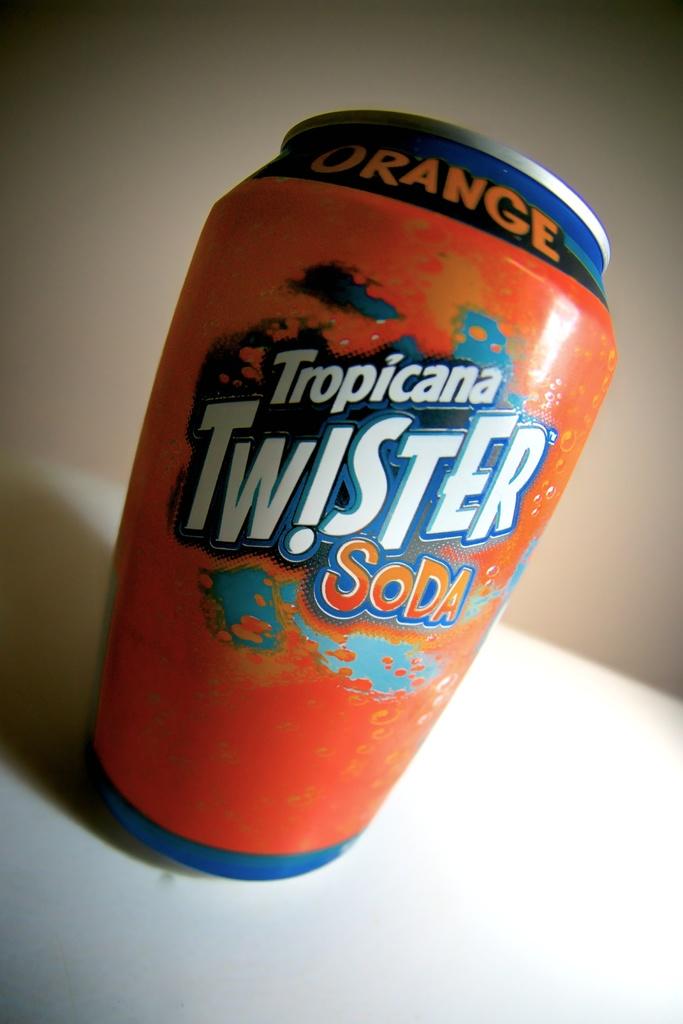What flavour is this soda?
Give a very brief answer. Orange. Is this a soda?
Offer a very short reply. Yes. 